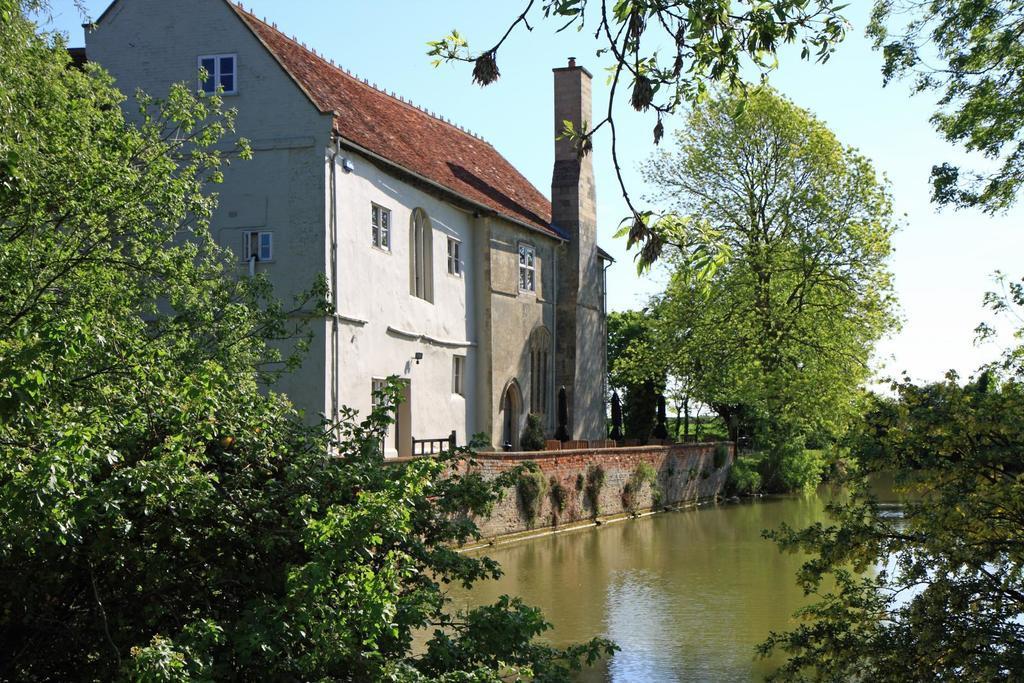Can you describe this image briefly? In this image on the left side there is a house and there is a tower, at the bottom there is river and there are some trees. At the top there is sky. 